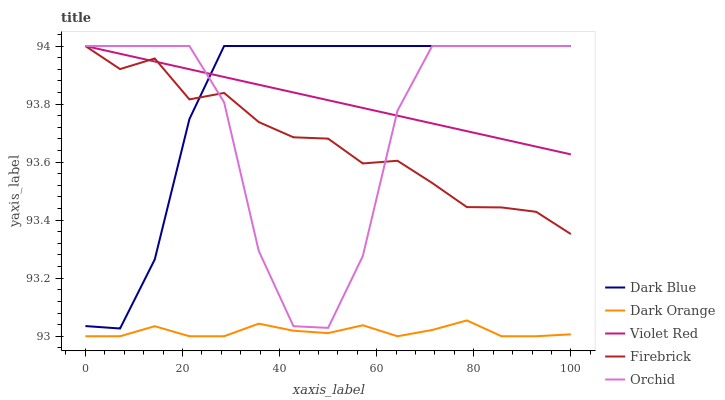Does Violet Red have the minimum area under the curve?
Answer yes or no. No. Does Violet Red have the maximum area under the curve?
Answer yes or no. No. Is Orchid the smoothest?
Answer yes or no. No. Is Violet Red the roughest?
Answer yes or no. No. Does Orchid have the lowest value?
Answer yes or no. No. Does Dark Orange have the highest value?
Answer yes or no. No. Is Dark Orange less than Dark Blue?
Answer yes or no. Yes. Is Violet Red greater than Dark Orange?
Answer yes or no. Yes. Does Dark Orange intersect Dark Blue?
Answer yes or no. No. 